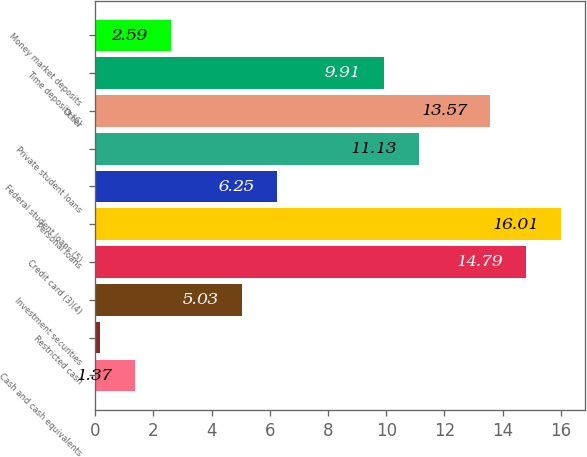Convert chart. <chart><loc_0><loc_0><loc_500><loc_500><bar_chart><fcel>Cash and cash equivalents<fcel>Restricted cash<fcel>Investment securities<fcel>Credit card (3)(4)<fcel>Personal loans<fcel>Federal student loans (5)<fcel>Private student loans<fcel>Other<fcel>Time deposits (6)<fcel>Money market deposits<nl><fcel>1.37<fcel>0.15<fcel>5.03<fcel>14.79<fcel>16.01<fcel>6.25<fcel>11.13<fcel>13.57<fcel>9.91<fcel>2.59<nl></chart> 